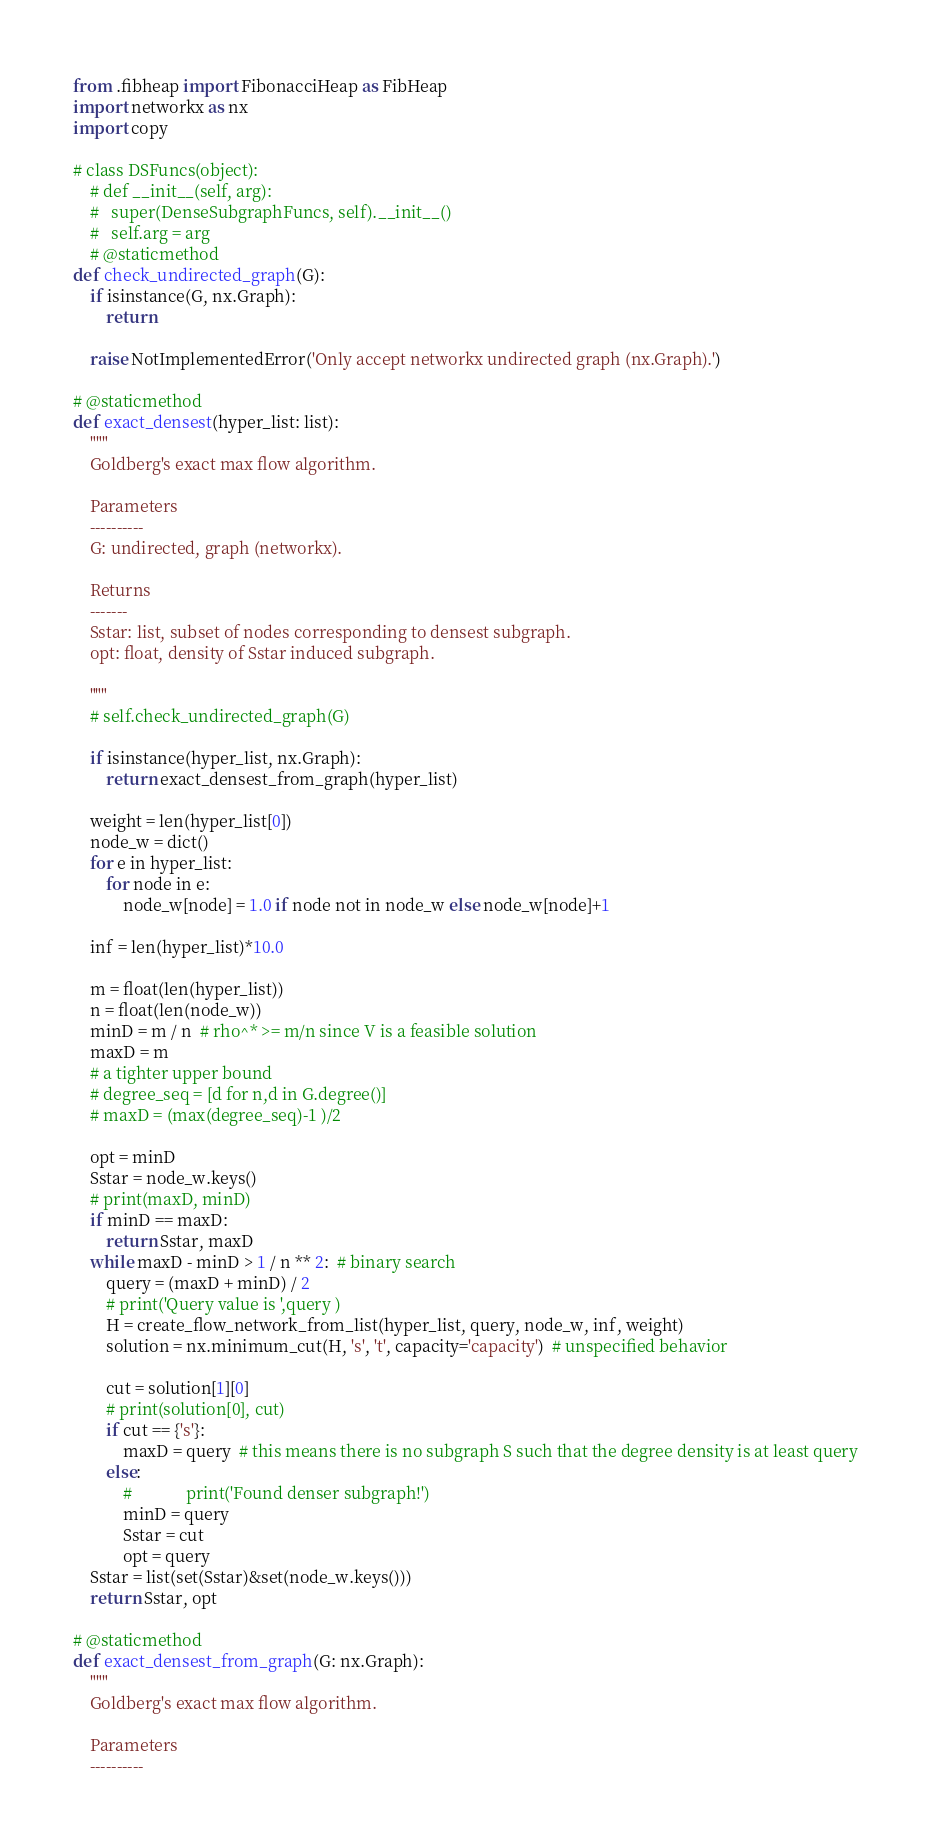Convert code to text. <code><loc_0><loc_0><loc_500><loc_500><_Python_>from .fibheap import FibonacciHeap as FibHeap
import networkx as nx
import copy

# class DSFuncs(object):
    # def __init__(self, arg):
    #   super(DenseSubgraphFuncs, self).__init__()
    #   self.arg = arg
    # @staticmethod
def check_undirected_graph(G):
    if isinstance(G, nx.Graph):
        return

    raise NotImplementedError('Only accept networkx undirected graph (nx.Graph).')

# @staticmethod
def exact_densest(hyper_list: list):
    """
    Goldberg's exact max flow algorithm.

    Parameters
    ----------
    G: undirected, graph (networkx).

    Returns
    -------
    Sstar: list, subset of nodes corresponding to densest subgraph.
    opt: float, density of Sstar induced subgraph.

    """
    # self.check_undirected_graph(G)

    if isinstance(hyper_list, nx.Graph):
        return exact_densest_from_graph(hyper_list)

    weight = len(hyper_list[0])
    node_w = dict()
    for e in hyper_list:
        for node in e:
            node_w[node] = 1.0 if node not in node_w else node_w[node]+1

    inf = len(hyper_list)*10.0

    m = float(len(hyper_list))
    n = float(len(node_w))
    minD = m / n  # rho^* >= m/n since V is a feasible solution
    maxD = m
    # a tighter upper bound
    # degree_seq = [d for n,d in G.degree()]
    # maxD = (max(degree_seq)-1 )/2

    opt = minD
    Sstar = node_w.keys()
    # print(maxD, minD)
    if minD == maxD:
        return Sstar, maxD
    while maxD - minD > 1 / n ** 2:  # binary search
        query = (maxD + minD) / 2
        # print('Query value is ',query )
        H = create_flow_network_from_list(hyper_list, query, node_w, inf, weight)
        solution = nx.minimum_cut(H, 's', 't', capacity='capacity')  # unspecified behavior
        
        cut = solution[1][0]
        # print(solution[0], cut)
        if cut == {'s'}:
            maxD = query  # this means there is no subgraph S such that the degree density is at least query
        else:
            #             print('Found denser subgraph!')
            minD = query
            Sstar = cut
            opt = query
    Sstar = list(set(Sstar)&set(node_w.keys()))
    return Sstar, opt

# @staticmethod
def exact_densest_from_graph(G: nx.Graph):
    """
    Goldberg's exact max flow algorithm.

    Parameters
    ----------</code> 